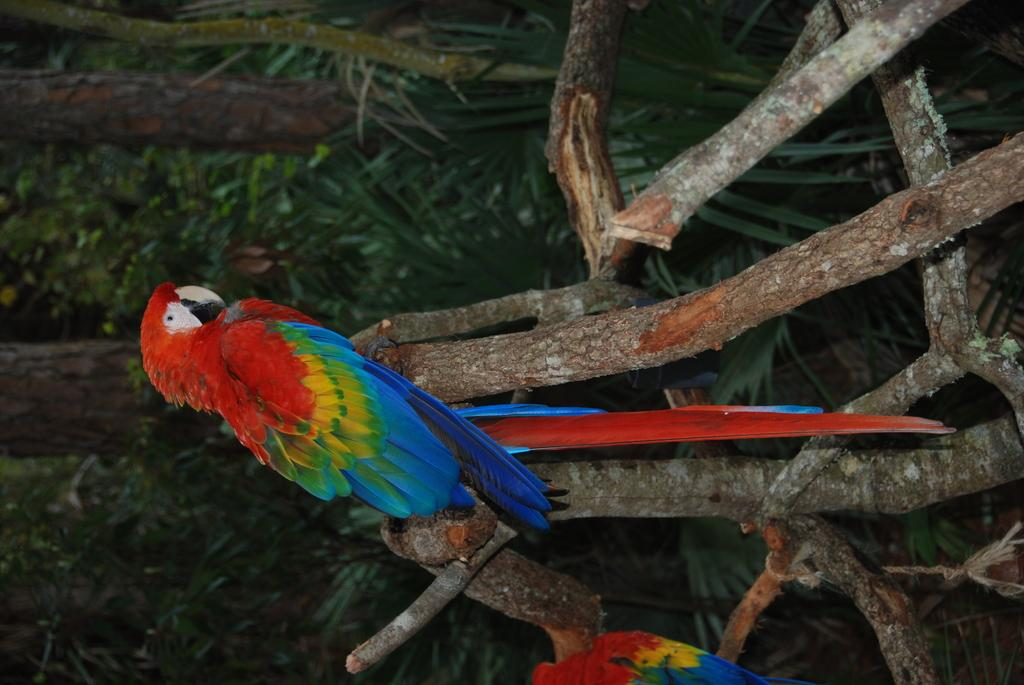What type of vegetation can be seen in the image? There is grass in the image. What animals are present in the image? There are birds in the image. What objects made of wood can be seen in the image? There are wooden sticks in the image. What type of dinner is being served in the image? There is no dinner present in the image; it features grass, birds, and wooden sticks. What type of frame surrounds the image? The provided facts do not mention a frame, so we cannot determine if there is one or what type it might be. 